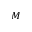<formula> <loc_0><loc_0><loc_500><loc_500>M</formula> 